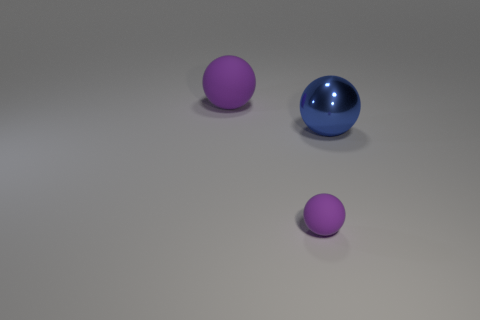Subtract all purple matte spheres. How many spheres are left? 1 Add 1 small red rubber objects. How many objects exist? 4 Add 2 metal balls. How many metal balls exist? 3 Subtract 0 blue blocks. How many objects are left? 3 Subtract all tiny purple cylinders. Subtract all big purple things. How many objects are left? 2 Add 1 metallic spheres. How many metallic spheres are left? 2 